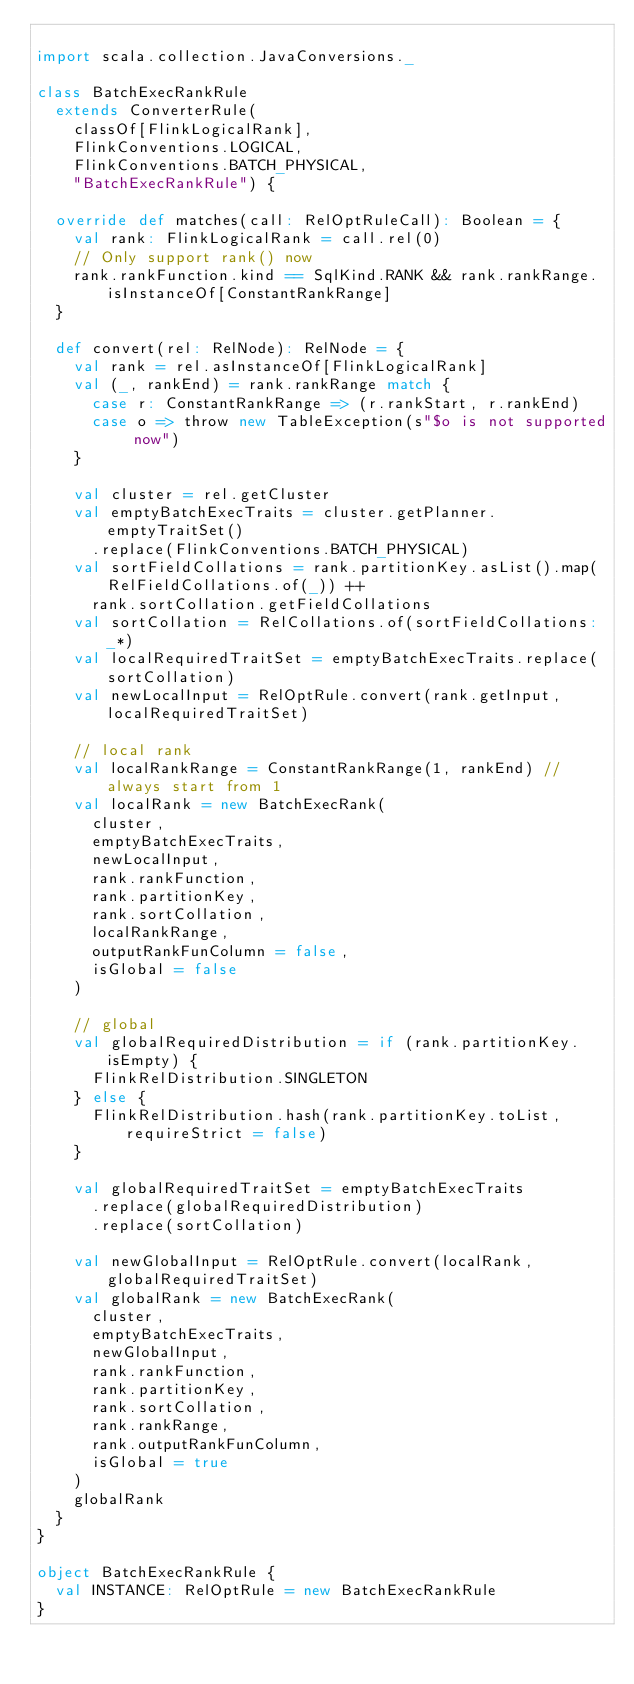<code> <loc_0><loc_0><loc_500><loc_500><_Scala_>
import scala.collection.JavaConversions._

class BatchExecRankRule
  extends ConverterRule(
    classOf[FlinkLogicalRank],
    FlinkConventions.LOGICAL,
    FlinkConventions.BATCH_PHYSICAL,
    "BatchExecRankRule") {

  override def matches(call: RelOptRuleCall): Boolean = {
    val rank: FlinkLogicalRank = call.rel(0)
    // Only support rank() now
    rank.rankFunction.kind == SqlKind.RANK && rank.rankRange.isInstanceOf[ConstantRankRange]
  }

  def convert(rel: RelNode): RelNode = {
    val rank = rel.asInstanceOf[FlinkLogicalRank]
    val (_, rankEnd) = rank.rankRange match {
      case r: ConstantRankRange => (r.rankStart, r.rankEnd)
      case o => throw new TableException(s"$o is not supported now")
    }

    val cluster = rel.getCluster
    val emptyBatchExecTraits = cluster.getPlanner.emptyTraitSet()
      .replace(FlinkConventions.BATCH_PHYSICAL)
    val sortFieldCollations = rank.partitionKey.asList().map(RelFieldCollations.of(_)) ++
      rank.sortCollation.getFieldCollations
    val sortCollation = RelCollations.of(sortFieldCollations: _*)
    val localRequiredTraitSet = emptyBatchExecTraits.replace(sortCollation)
    val newLocalInput = RelOptRule.convert(rank.getInput, localRequiredTraitSet)

    // local rank
    val localRankRange = ConstantRankRange(1, rankEnd) // always start from 1
    val localRank = new BatchExecRank(
      cluster,
      emptyBatchExecTraits,
      newLocalInput,
      rank.rankFunction,
      rank.partitionKey,
      rank.sortCollation,
      localRankRange,
      outputRankFunColumn = false,
      isGlobal = false
    )

    // global
    val globalRequiredDistribution = if (rank.partitionKey.isEmpty) {
      FlinkRelDistribution.SINGLETON
    } else {
      FlinkRelDistribution.hash(rank.partitionKey.toList, requireStrict = false)
    }

    val globalRequiredTraitSet = emptyBatchExecTraits
      .replace(globalRequiredDistribution)
      .replace(sortCollation)

    val newGlobalInput = RelOptRule.convert(localRank, globalRequiredTraitSet)
    val globalRank = new BatchExecRank(
      cluster,
      emptyBatchExecTraits,
      newGlobalInput,
      rank.rankFunction,
      rank.partitionKey,
      rank.sortCollation,
      rank.rankRange,
      rank.outputRankFunColumn,
      isGlobal = true
    )
    globalRank
  }
}

object BatchExecRankRule {
  val INSTANCE: RelOptRule = new BatchExecRankRule
}
</code> 